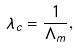<formula> <loc_0><loc_0><loc_500><loc_500>\lambda _ { c } = \frac { 1 } { \Lambda _ { m } } ,</formula> 